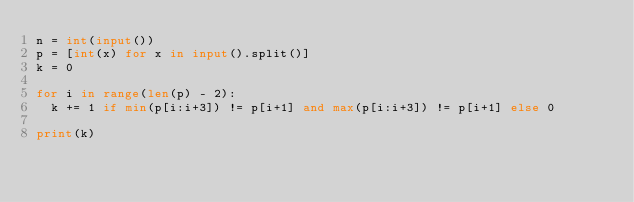<code> <loc_0><loc_0><loc_500><loc_500><_Python_>n = int(input())
p = [int(x) for x in input().split()]
k = 0

for i in range(len(p) - 2):
  k += 1 if min(p[i:i+3]) != p[i+1] and max(p[i:i+3]) != p[i+1] else 0
  
print(k)</code> 